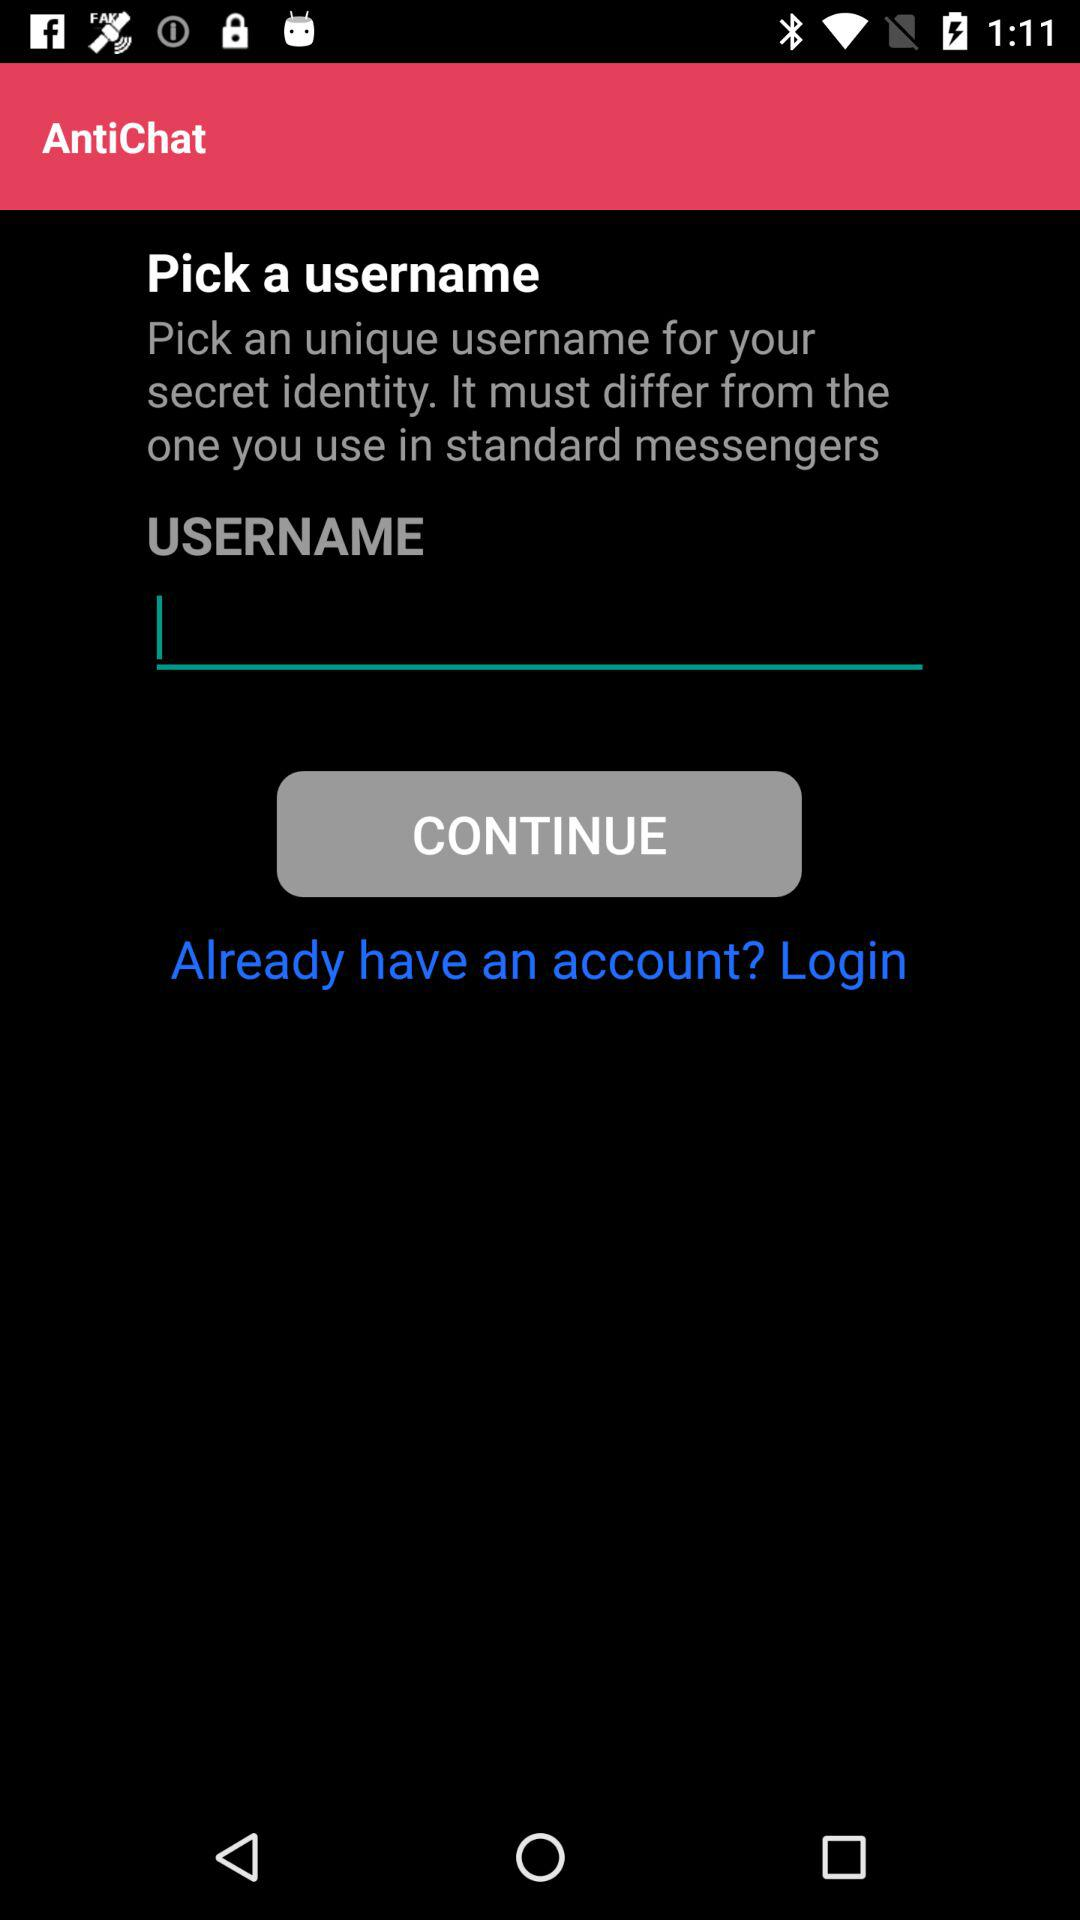What is the name of the application? The name of the application is "AntiChat". 